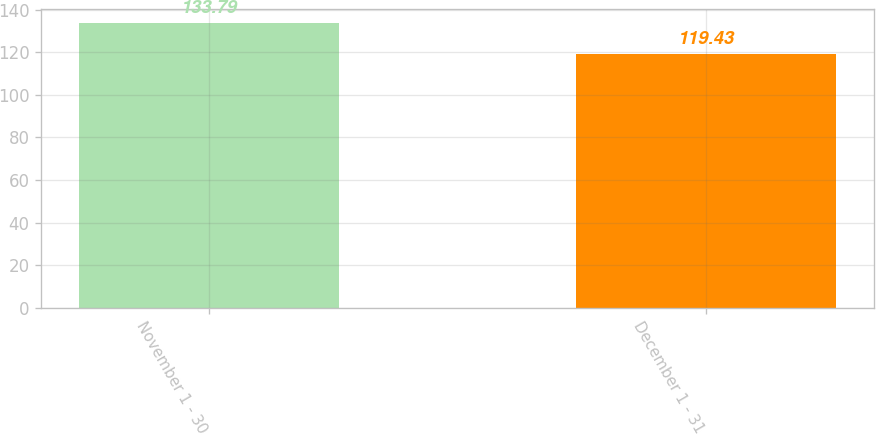Convert chart. <chart><loc_0><loc_0><loc_500><loc_500><bar_chart><fcel>November 1 - 30<fcel>December 1 - 31<nl><fcel>133.79<fcel>119.43<nl></chart> 